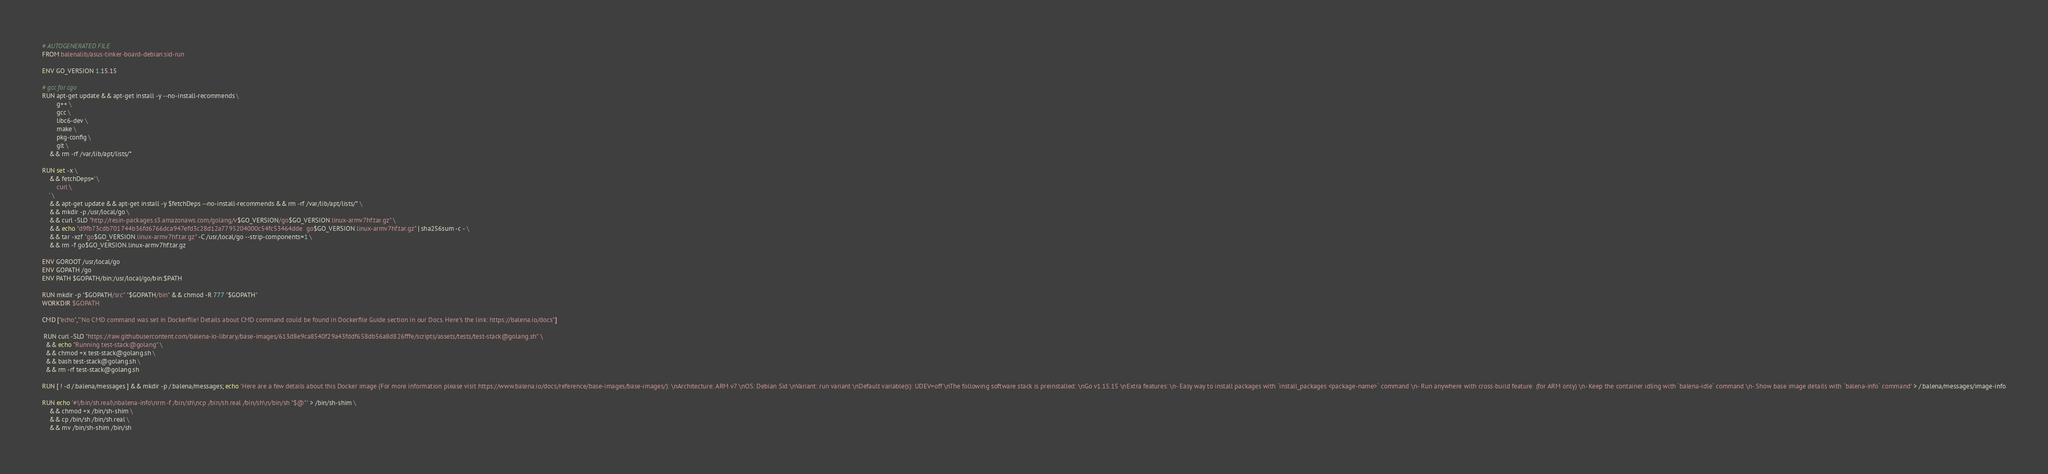Convert code to text. <code><loc_0><loc_0><loc_500><loc_500><_Dockerfile_># AUTOGENERATED FILE
FROM balenalib/asus-tinker-board-debian:sid-run

ENV GO_VERSION 1.15.15

# gcc for cgo
RUN apt-get update && apt-get install -y --no-install-recommends \
		g++ \
		gcc \
		libc6-dev \
		make \
		pkg-config \
		git \
	&& rm -rf /var/lib/apt/lists/*

RUN set -x \
	&& fetchDeps=' \
		curl \
	' \
	&& apt-get update && apt-get install -y $fetchDeps --no-install-recommends && rm -rf /var/lib/apt/lists/* \
	&& mkdir -p /usr/local/go \
	&& curl -SLO "http://resin-packages.s3.amazonaws.com/golang/v$GO_VERSION/go$GO_VERSION.linux-armv7hf.tar.gz" \
	&& echo "d9fb73cdb701744b36fd6766dca947efd3c28d12a7795204000c54fc53464dde  go$GO_VERSION.linux-armv7hf.tar.gz" | sha256sum -c - \
	&& tar -xzf "go$GO_VERSION.linux-armv7hf.tar.gz" -C /usr/local/go --strip-components=1 \
	&& rm -f go$GO_VERSION.linux-armv7hf.tar.gz

ENV GOROOT /usr/local/go
ENV GOPATH /go
ENV PATH $GOPATH/bin:/usr/local/go/bin:$PATH

RUN mkdir -p "$GOPATH/src" "$GOPATH/bin" && chmod -R 777 "$GOPATH"
WORKDIR $GOPATH

CMD ["echo","'No CMD command was set in Dockerfile! Details about CMD command could be found in Dockerfile Guide section in our Docs. Here's the link: https://balena.io/docs"]

 RUN curl -SLO "https://raw.githubusercontent.com/balena-io-library/base-images/613d8e9ca8540f29a43fddf658db56a8d826fffe/scripts/assets/tests/test-stack@golang.sh" \
  && echo "Running test-stack@golang" \
  && chmod +x test-stack@golang.sh \
  && bash test-stack@golang.sh \
  && rm -rf test-stack@golang.sh 

RUN [ ! -d /.balena/messages ] && mkdir -p /.balena/messages; echo 'Here are a few details about this Docker image (For more information please visit https://www.balena.io/docs/reference/base-images/base-images/): \nArchitecture: ARM v7 \nOS: Debian Sid \nVariant: run variant \nDefault variable(s): UDEV=off \nThe following software stack is preinstalled: \nGo v1.15.15 \nExtra features: \n- Easy way to install packages with `install_packages <package-name>` command \n- Run anywhere with cross-build feature  (for ARM only) \n- Keep the container idling with `balena-idle` command \n- Show base image details with `balena-info` command' > /.balena/messages/image-info

RUN echo '#!/bin/sh.real\nbalena-info\nrm -f /bin/sh\ncp /bin/sh.real /bin/sh\n/bin/sh "$@"' > /bin/sh-shim \
	&& chmod +x /bin/sh-shim \
	&& cp /bin/sh /bin/sh.real \
	&& mv /bin/sh-shim /bin/sh</code> 